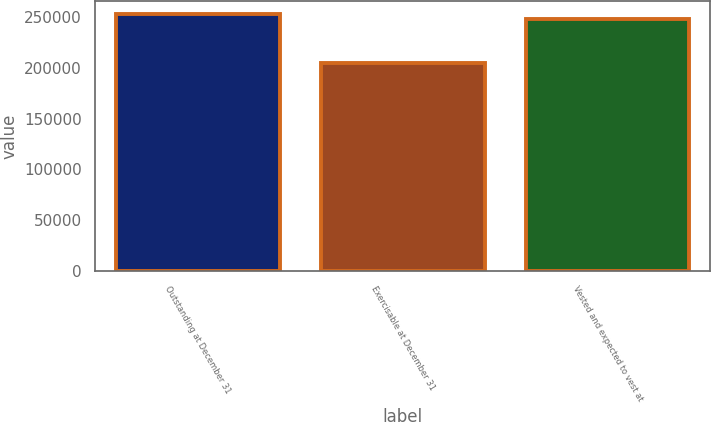Convert chart to OTSL. <chart><loc_0><loc_0><loc_500><loc_500><bar_chart><fcel>Outstanding at December 31<fcel>Exercisable at December 31<fcel>Vested and expected to vest at<nl><fcel>252302<fcel>204860<fcel>247784<nl></chart> 